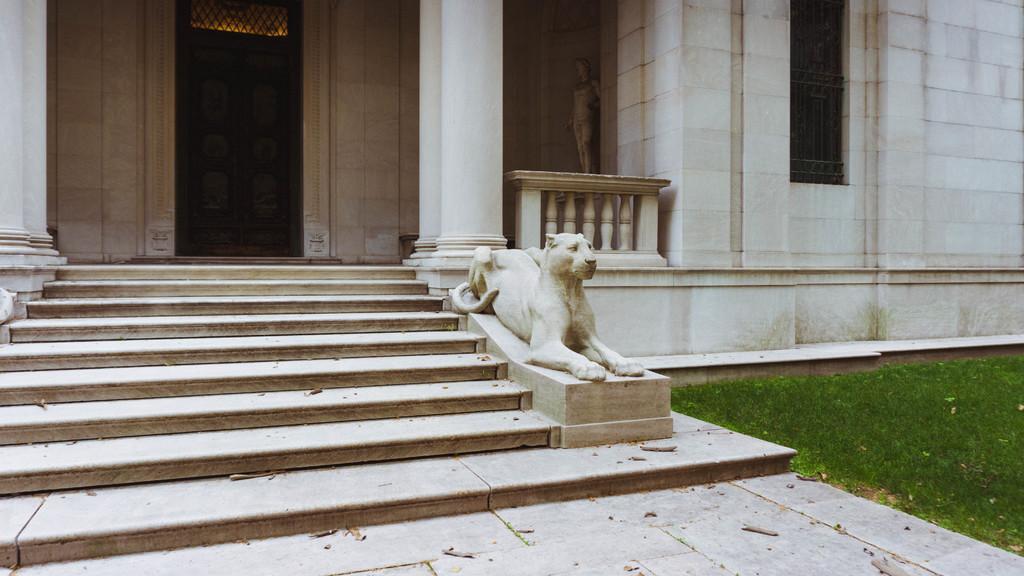Can you describe this image briefly? In the center of the image there is a building. At the bottom we can see sculpture and stairs. On the right there is grass. 